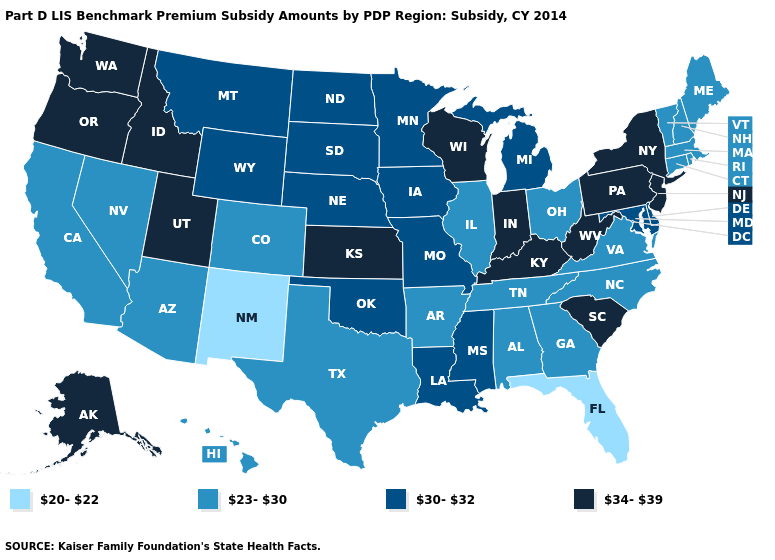Does New York have the lowest value in the Northeast?
Concise answer only. No. What is the value of Idaho?
Keep it brief. 34-39. Name the states that have a value in the range 23-30?
Short answer required. Alabama, Arizona, Arkansas, California, Colorado, Connecticut, Georgia, Hawaii, Illinois, Maine, Massachusetts, Nevada, New Hampshire, North Carolina, Ohio, Rhode Island, Tennessee, Texas, Vermont, Virginia. What is the value of Pennsylvania?
Keep it brief. 34-39. Name the states that have a value in the range 34-39?
Quick response, please. Alaska, Idaho, Indiana, Kansas, Kentucky, New Jersey, New York, Oregon, Pennsylvania, South Carolina, Utah, Washington, West Virginia, Wisconsin. Which states hav the highest value in the South?
Write a very short answer. Kentucky, South Carolina, West Virginia. What is the highest value in the South ?
Quick response, please. 34-39. What is the highest value in states that border Tennessee?
Write a very short answer. 34-39. What is the lowest value in the MidWest?
Answer briefly. 23-30. What is the lowest value in the USA?
Keep it brief. 20-22. Does the map have missing data?
Quick response, please. No. What is the value of Georgia?
Be succinct. 23-30. Does Florida have a lower value than New Mexico?
Write a very short answer. No. What is the value of Montana?
Quick response, please. 30-32. What is the value of Arizona?
Write a very short answer. 23-30. 